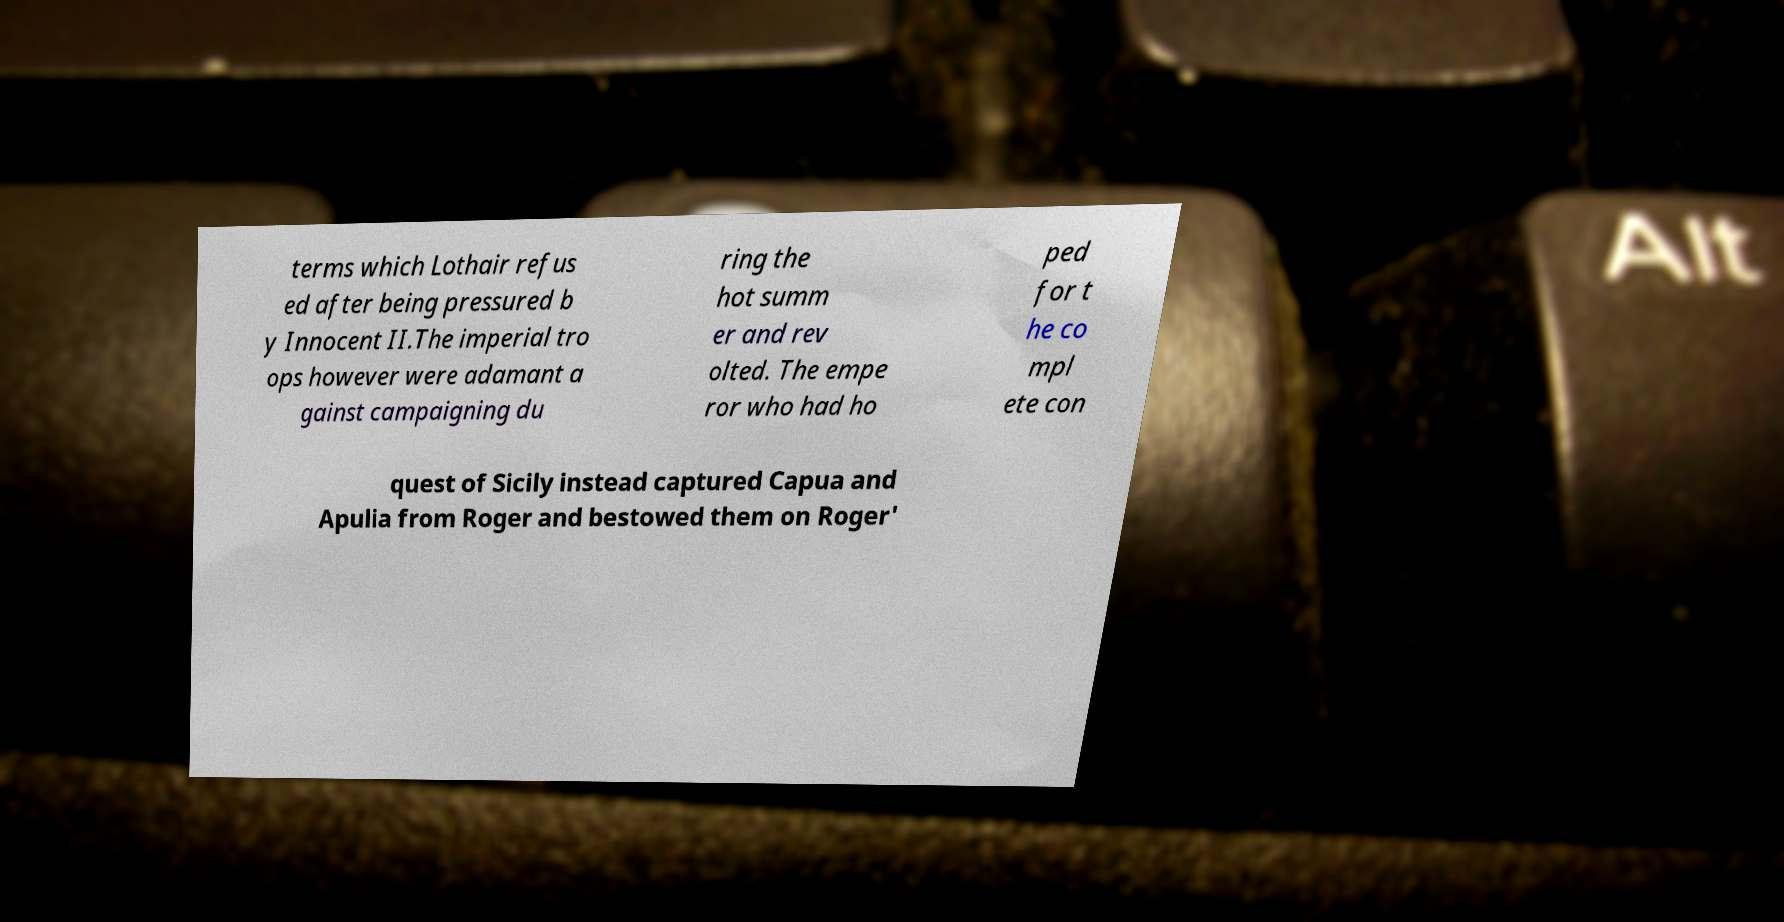Could you assist in decoding the text presented in this image and type it out clearly? terms which Lothair refus ed after being pressured b y Innocent II.The imperial tro ops however were adamant a gainst campaigning du ring the hot summ er and rev olted. The empe ror who had ho ped for t he co mpl ete con quest of Sicily instead captured Capua and Apulia from Roger and bestowed them on Roger' 